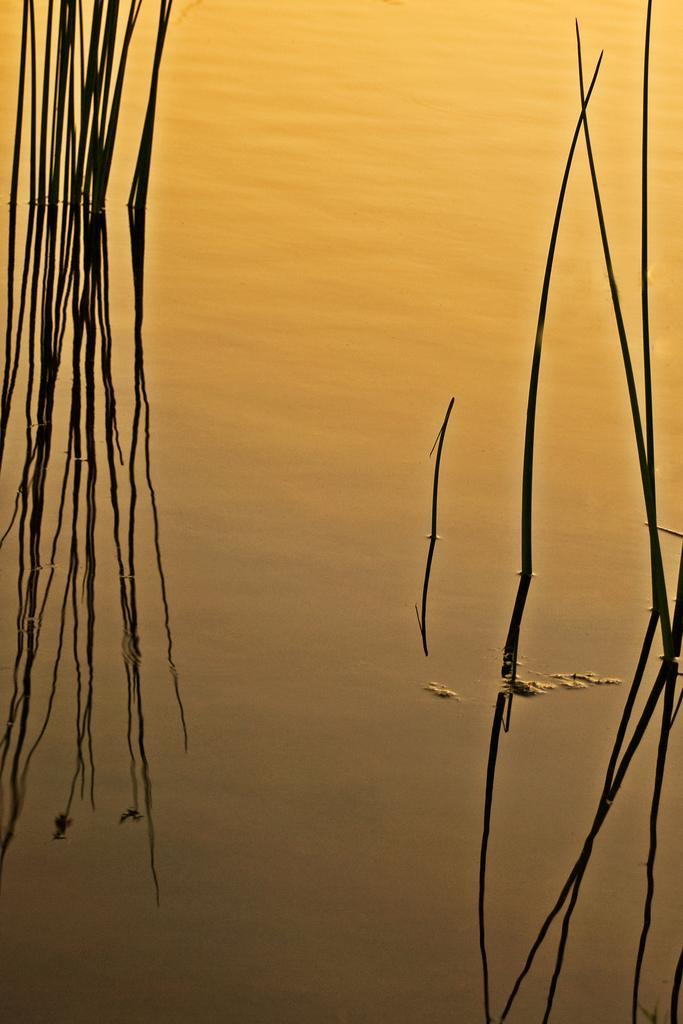Describe this image in one or two sentences. In this image we can see plants and water. 